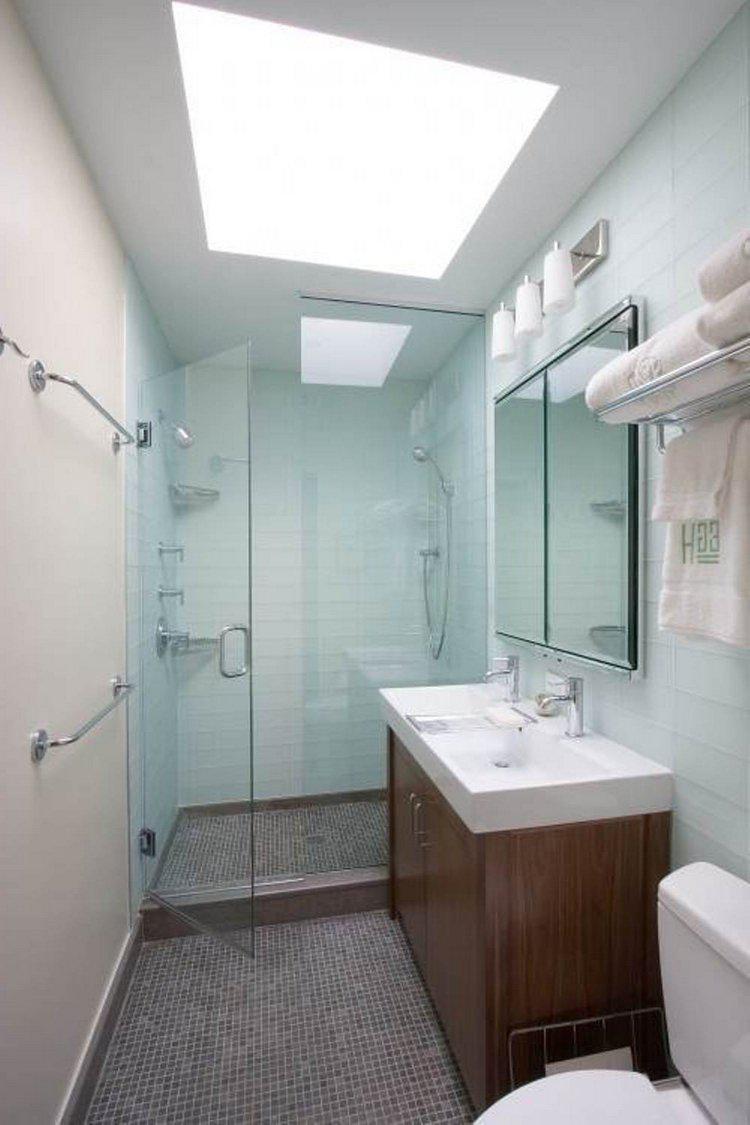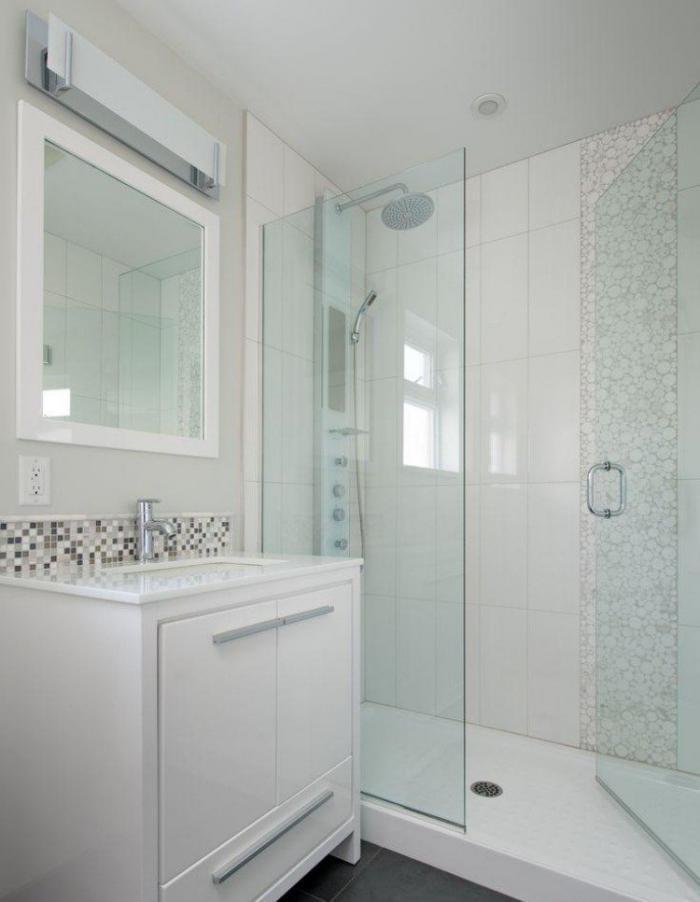The first image is the image on the left, the second image is the image on the right. Assess this claim about the two images: "One bathroom has a squarish mirror above a rectangular white sink and dark tile arranged like brick in the shower area.". Correct or not? Answer yes or no. No. 